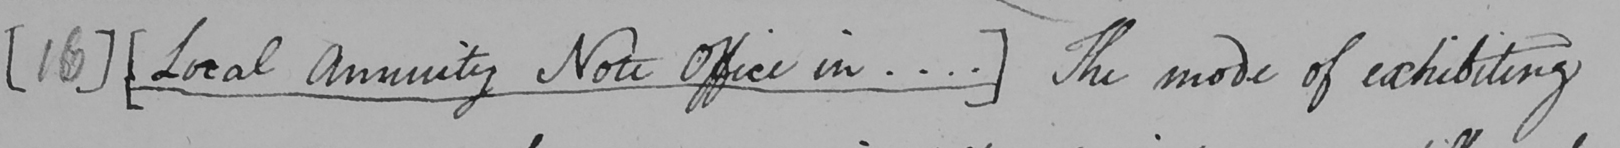What does this handwritten line say? [ 16 ]   [ Local Annuity Note Office in ... . ]  The mode of exhibiting 